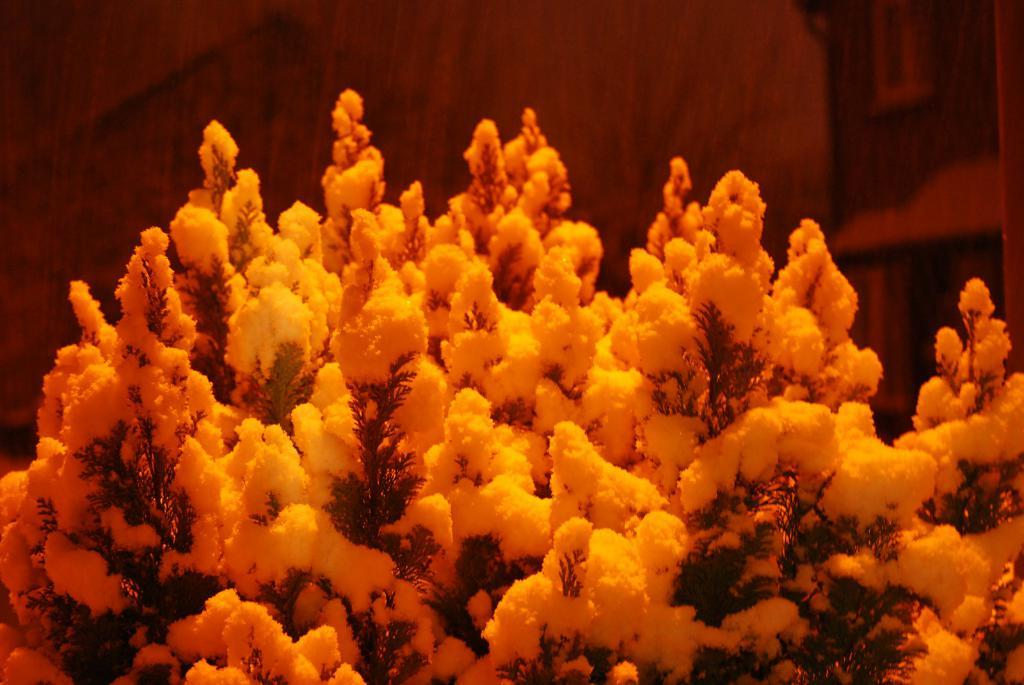What is the main subject of the image? There is a tree in the image. How is the tree affected by the weather? The tree is covered with snow. Can you describe the background of the image? The background of the image appears blurry. Are there any leaves visible on the tree? Yes, leaves are visible on the tree. What decision does the wind make in the image? There is no wind present in the image, and therefore no decision can be made by it. 